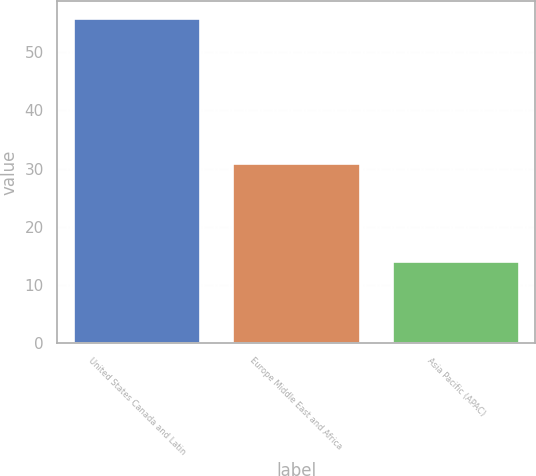Convert chart. <chart><loc_0><loc_0><loc_500><loc_500><bar_chart><fcel>United States Canada and Latin<fcel>Europe Middle East and Africa<fcel>Asia Pacific (APAC)<nl><fcel>56<fcel>31<fcel>14<nl></chart> 